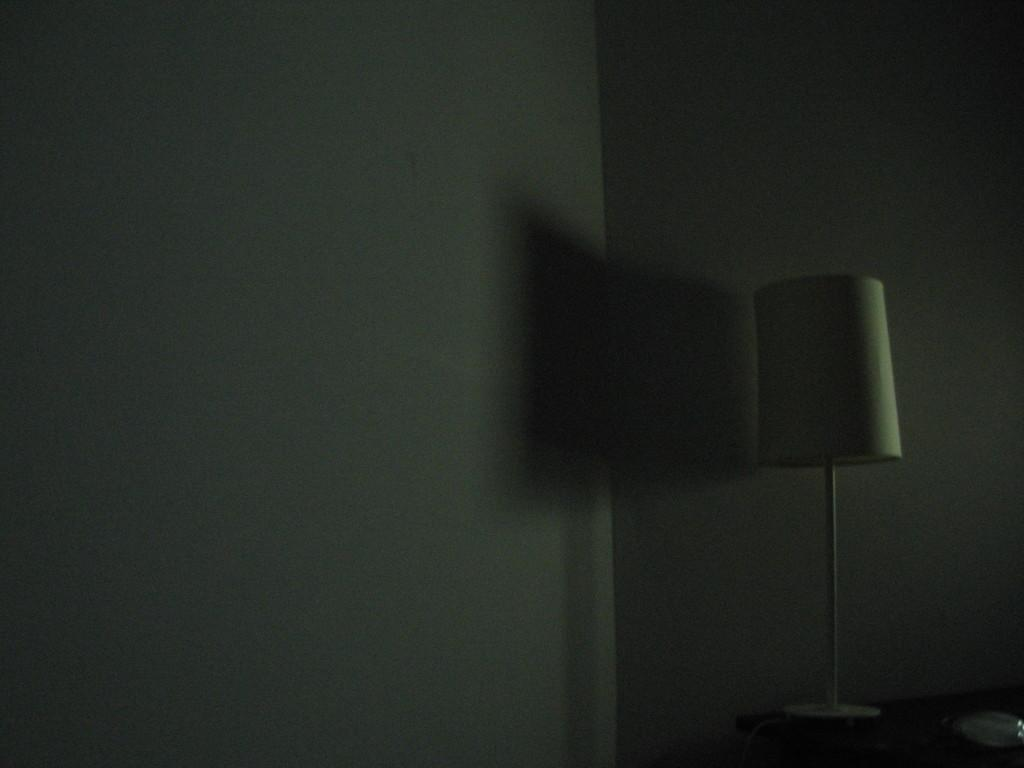What object can be seen in the image that provides light? There is a lamp in the image. Where is the lamp located? The lamp is present on a table. What page number is the lamp on in the image? The lamp is not on a page, so there is no page number associated with it. 